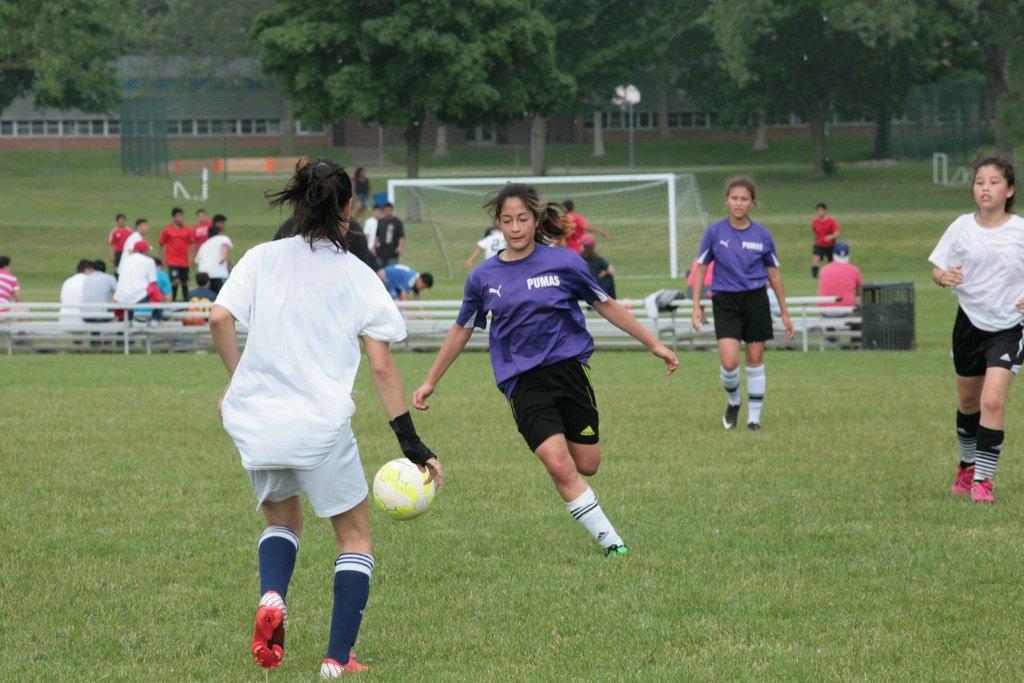What is the brand of the purple uniform shirt?
Provide a succinct answer. Pumas. How many letters are in the team name?
Your response must be concise. 5. 